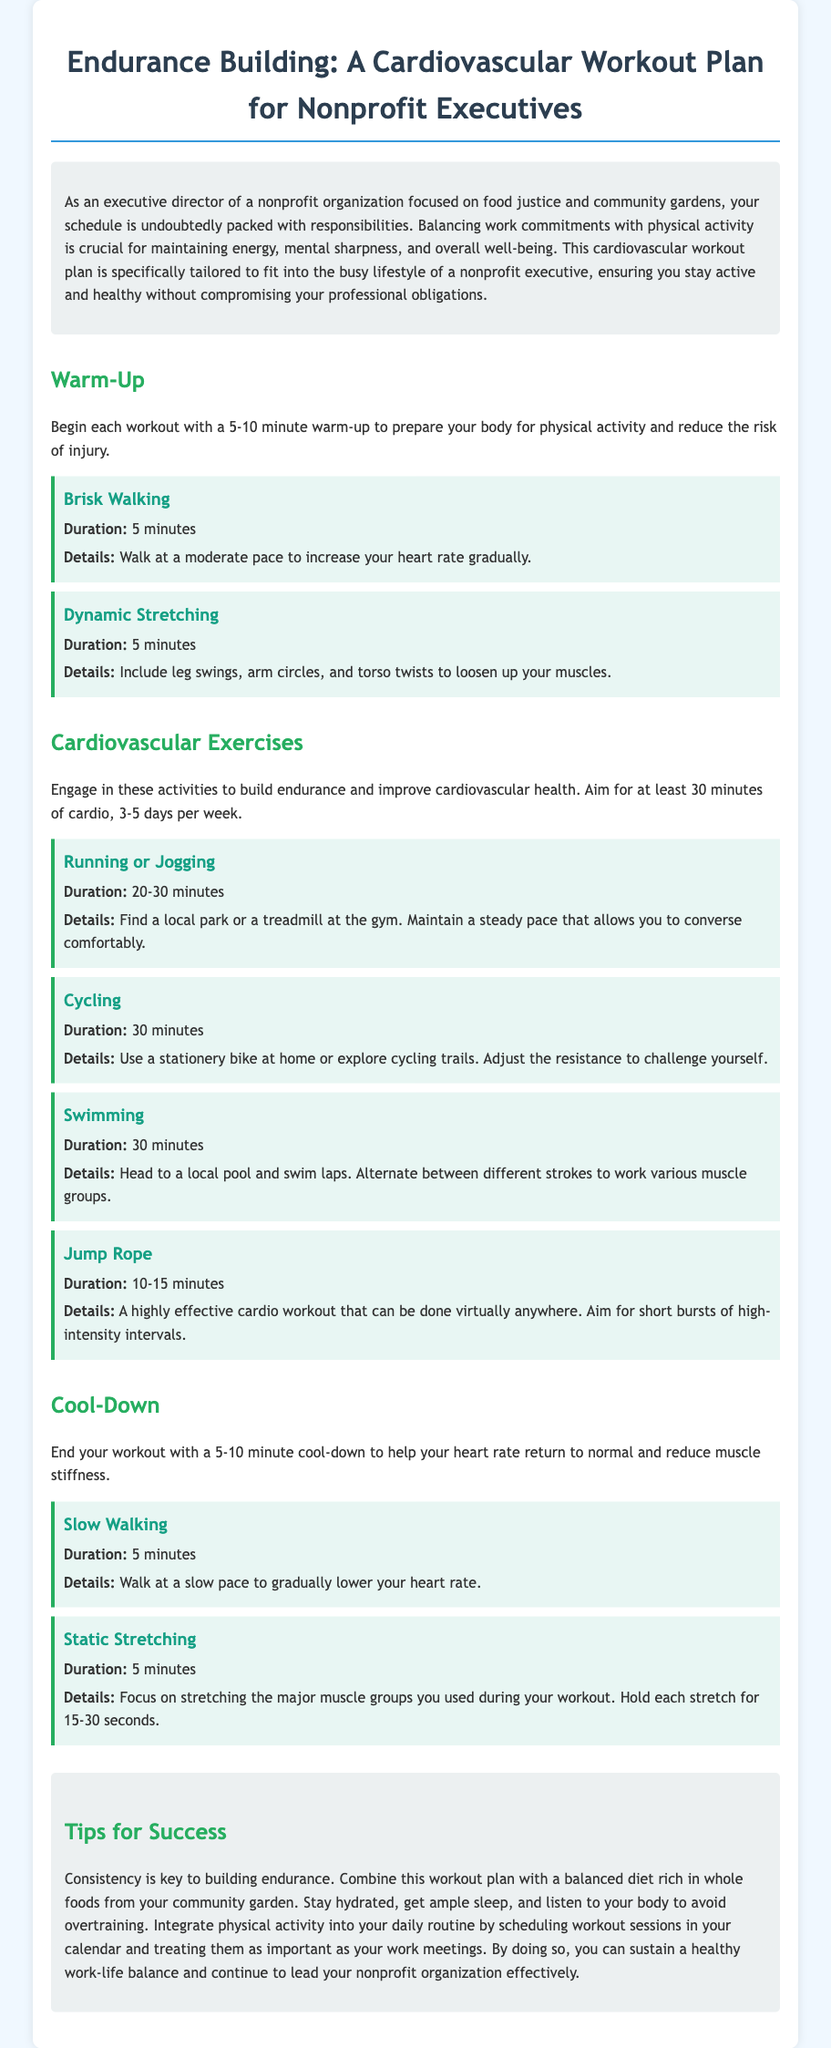What is the main focus of this workout plan? The workout plan is specifically tailored for nonprofit executives, ensuring they stay active and healthy while balancing their professional obligations.
Answer: Food justice and community gardens How long should the warm-up last? The document states to begin each workout with a warm-up to prepare the body, lasting 5-10 minutes.
Answer: 5-10 minutes What is the duration of the running or jogging activity? The recommended duration for running or jogging in the workout plan is specified.
Answer: 20-30 minutes What type of stretching is recommended for the cool-down? The cool-down section mentions a specific type of stretching activity to help in recovery.
Answer: Static Stretching How many days a week should cardiovascular exercises be performed? The document specifies the frequency of engaging in cardiovascular exercises per week.
Answer: 3-5 days per week What is one of the tips provided for success in building endurance? The document includes tips that mention actions beneficial for maintaining an active lifestyle.
Answer: Consistency What activity can be done virtually anywhere as a cardio workout? The workout plan lists a specific activity that is flexible in terms of location.
Answer: Jump Rope What is the recommended duration for the activity of cycling? The document provides a specific duration for cycling as part of the cardiovascular exercises.
Answer: 30 minutes What is suggested to be scheduled in your calendar to maintain a healthy work-life balance? The document recommends scheduling specific activities to manage time effectively.
Answer: Workout sessions 